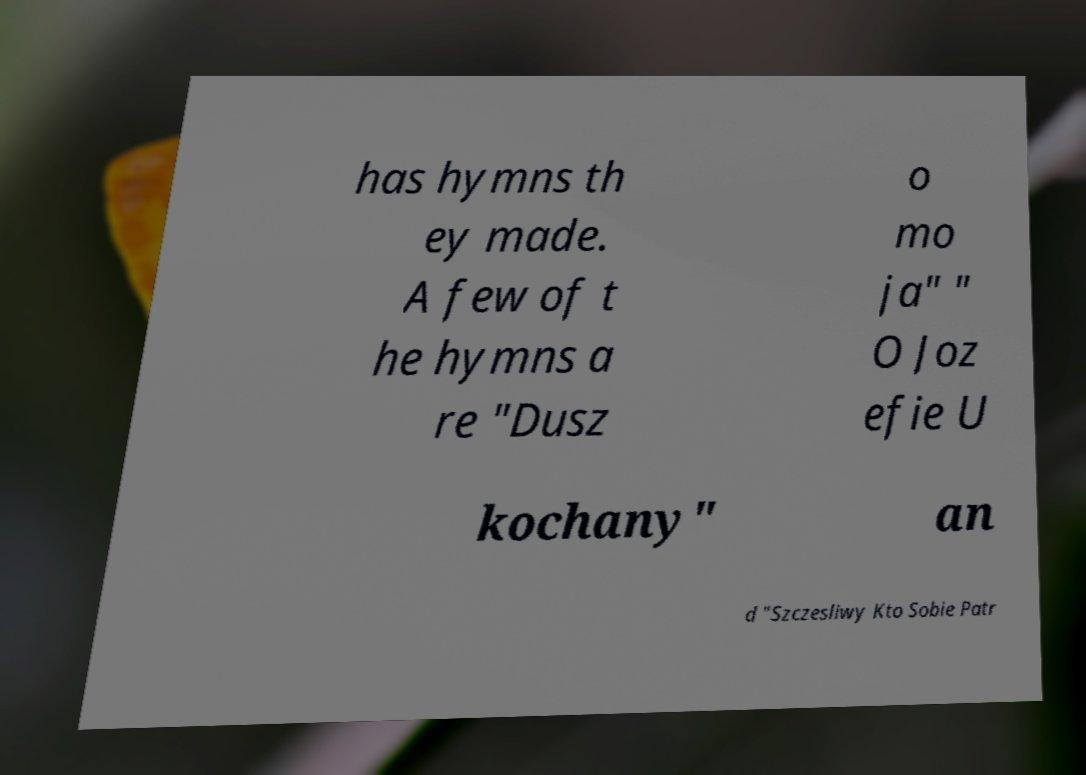What messages or text are displayed in this image? I need them in a readable, typed format. has hymns th ey made. A few of t he hymns a re "Dusz o mo ja" " O Joz efie U kochany" an d "Szczesliwy Kto Sobie Patr 